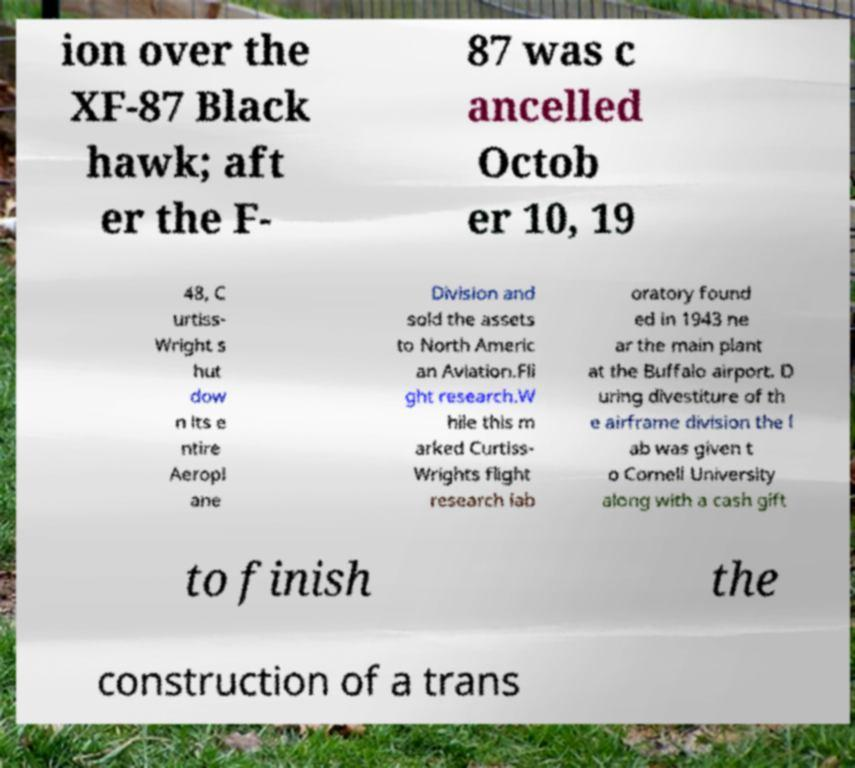I need the written content from this picture converted into text. Can you do that? ion over the XF-87 Black hawk; aft er the F- 87 was c ancelled Octob er 10, 19 48, C urtiss- Wright s hut dow n its e ntire Aeropl ane Division and sold the assets to North Americ an Aviation.Fli ght research.W hile this m arked Curtiss- Wrights flight research lab oratory found ed in 1943 ne ar the main plant at the Buffalo airport. D uring divestiture of th e airframe division the l ab was given t o Cornell University along with a cash gift to finish the construction of a trans 